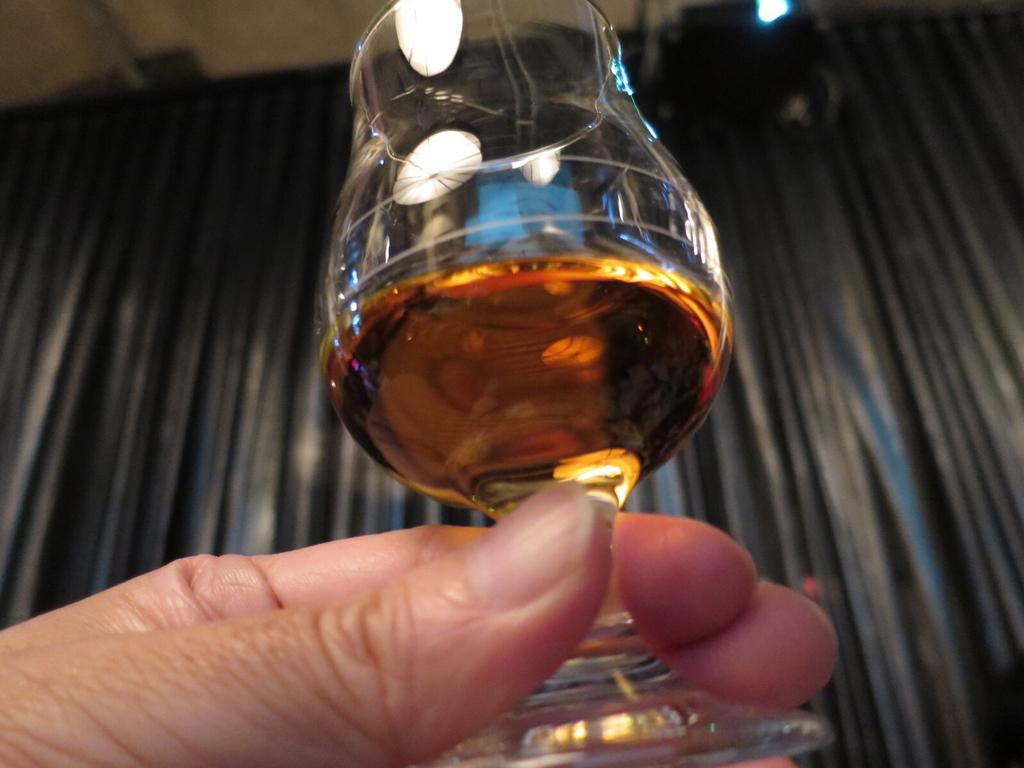What can be seen in the image that belongs to a person? There is a person's hand in the image. What is the person holding in the image? The person is holding a glass of drink. What can be seen in the background of the image? There are curtains in the background of the image. What is the aftermath of the road accident in the image? There is no road accident or aftermath present in the image; it only features a person's hand holding a glass of drink and curtains in the background. 